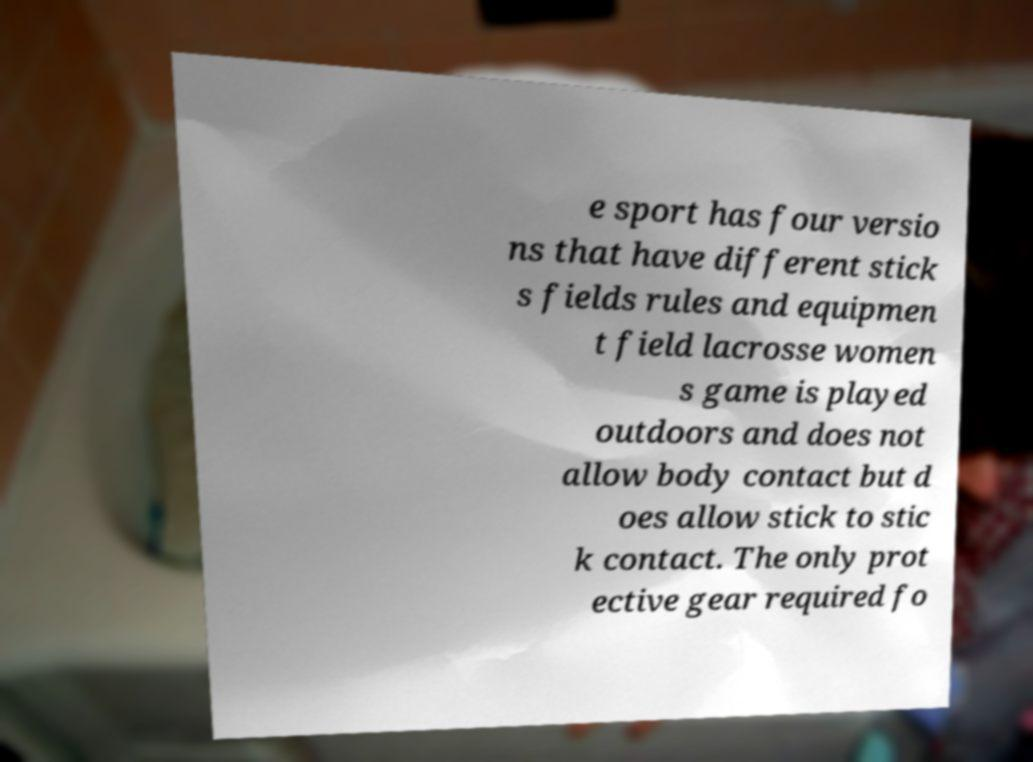There's text embedded in this image that I need extracted. Can you transcribe it verbatim? e sport has four versio ns that have different stick s fields rules and equipmen t field lacrosse women s game is played outdoors and does not allow body contact but d oes allow stick to stic k contact. The only prot ective gear required fo 